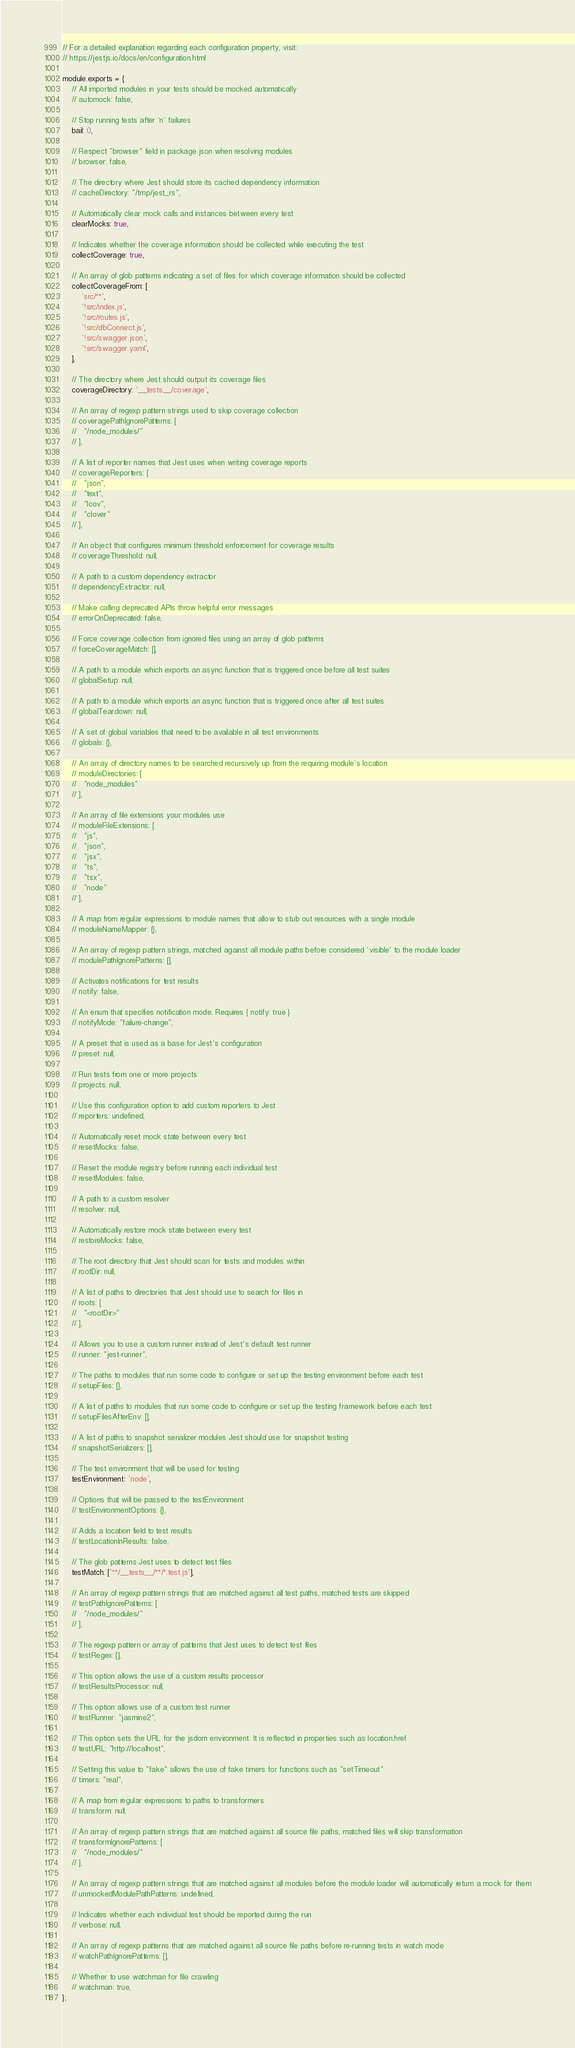<code> <loc_0><loc_0><loc_500><loc_500><_JavaScript_>// For a detailed explanation regarding each configuration property, visit:
// https://jestjs.io/docs/en/configuration.html

module.exports = {
    // All imported modules in your tests should be mocked automatically
    // automock: false,

    // Stop running tests after `n` failures
    bail: 0,

    // Respect "browser" field in package.json when resolving modules
    // browser: false,

    // The directory where Jest should store its cached dependency information
    // cacheDirectory: "/tmp/jest_rs",

    // Automatically clear mock calls and instances between every test
    clearMocks: true,

    // Indicates whether the coverage information should be collected while executing the test
    collectCoverage: true,

    // An array of glob patterns indicating a set of files for which coverage information should be collected
    collectCoverageFrom: [
        'src/**',
        '!src/index.js',
        '!src/routes.js',
        '!src/dbConnect.js',
        '!src/swagger.json',
        '!src/swagger.yaml',
    ],

    // The directory where Jest should output its coverage files
    coverageDirectory: '__tests__/coverage',

    // An array of regexp pattern strings used to skip coverage collection
    // coveragePathIgnorePatterns: [
    //   "/node_modules/"
    // ],

    // A list of reporter names that Jest uses when writing coverage reports
    // coverageReporters: [
    //   "json",
    //   "text",
    //   "lcov",
    //   "clover"
    // ],

    // An object that configures minimum threshold enforcement for coverage results
    // coverageThreshold: null,

    // A path to a custom dependency extractor
    // dependencyExtractor: null,

    // Make calling deprecated APIs throw helpful error messages
    // errorOnDeprecated: false,

    // Force coverage collection from ignored files using an array of glob patterns
    // forceCoverageMatch: [],

    // A path to a module which exports an async function that is triggered once before all test suites
    // globalSetup: null,

    // A path to a module which exports an async function that is triggered once after all test suites
    // globalTeardown: null,

    // A set of global variables that need to be available in all test environments
    // globals: {},

    // An array of directory names to be searched recursively up from the requiring module's location
    // moduleDirectories: [
    //   "node_modules"
    // ],

    // An array of file extensions your modules use
    // moduleFileExtensions: [
    //   "js",
    //   "json",
    //   "jsx",
    //   "ts",
    //   "tsx",
    //   "node"
    // ],

    // A map from regular expressions to module names that allow to stub out resources with a single module
    // moduleNameMapper: {},

    // An array of regexp pattern strings, matched against all module paths before considered 'visible' to the module loader
    // modulePathIgnorePatterns: [],

    // Activates notifications for test results
    // notify: false,

    // An enum that specifies notification mode. Requires { notify: true }
    // notifyMode: "failure-change",

    // A preset that is used as a base for Jest's configuration
    // preset: null,

    // Run tests from one or more projects
    // projects: null,

    // Use this configuration option to add custom reporters to Jest
    // reporters: undefined,

    // Automatically reset mock state between every test
    // resetMocks: false,

    // Reset the module registry before running each individual test
    // resetModules: false,

    // A path to a custom resolver
    // resolver: null,

    // Automatically restore mock state between every test
    // restoreMocks: false,

    // The root directory that Jest should scan for tests and modules within
    // rootDir: null,

    // A list of paths to directories that Jest should use to search for files in
    // roots: [
    //   "<rootDir>"
    // ],

    // Allows you to use a custom runner instead of Jest's default test runner
    // runner: "jest-runner",

    // The paths to modules that run some code to configure or set up the testing environment before each test
    // setupFiles: [],

    // A list of paths to modules that run some code to configure or set up the testing framework before each test
    // setupFilesAfterEnv: [],

    // A list of paths to snapshot serializer modules Jest should use for snapshot testing
    // snapshotSerializers: [],

    // The test environment that will be used for testing
    testEnvironment: 'node',

    // Options that will be passed to the testEnvironment
    // testEnvironmentOptions: {},

    // Adds a location field to test results
    // testLocationInResults: false,

    // The glob patterns Jest uses to detect test files
    testMatch: ['**/__tests__/**/*.test.js'],

    // An array of regexp pattern strings that are matched against all test paths, matched tests are skipped
    // testPathIgnorePatterns: [
    //   "/node_modules/"
    // ],

    // The regexp pattern or array of patterns that Jest uses to detect test files
    // testRegex: [],

    // This option allows the use of a custom results processor
    // testResultsProcessor: null,

    // This option allows use of a custom test runner
    // testRunner: "jasmine2",

    // This option sets the URL for the jsdom environment. It is reflected in properties such as location.href
    // testURL: "http://localhost",

    // Setting this value to "fake" allows the use of fake timers for functions such as "setTimeout"
    // timers: "real",

    // A map from regular expressions to paths to transformers
    // transform: null,

    // An array of regexp pattern strings that are matched against all source file paths, matched files will skip transformation
    // transformIgnorePatterns: [
    //   "/node_modules/"
    // ],

    // An array of regexp pattern strings that are matched against all modules before the module loader will automatically return a mock for them
    // unmockedModulePathPatterns: undefined,

    // Indicates whether each individual test should be reported during the run
    // verbose: null,

    // An array of regexp patterns that are matched against all source file paths before re-running tests in watch mode
    // watchPathIgnorePatterns: [],

    // Whether to use watchman for file crawling
    // watchman: true,
};
</code> 